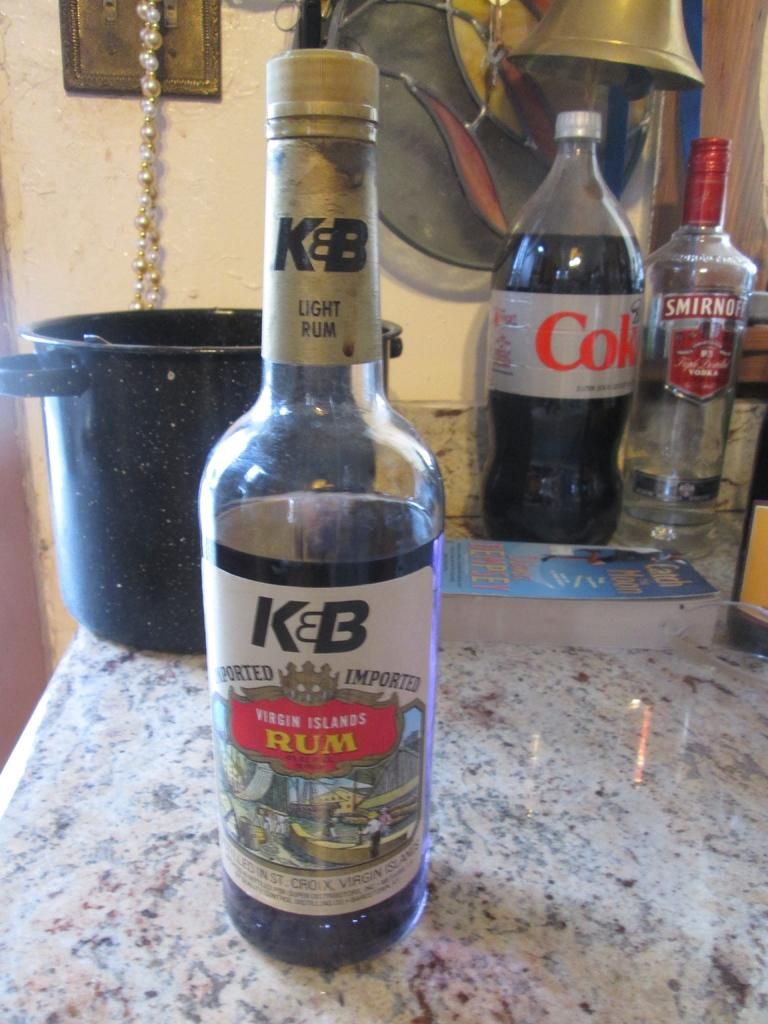<image>
Write a terse but informative summary of the picture. A bottle of K&B Light Rum accompanies a bottle of Diet Coke and Smirnoff Vodka on a grey countertop. 